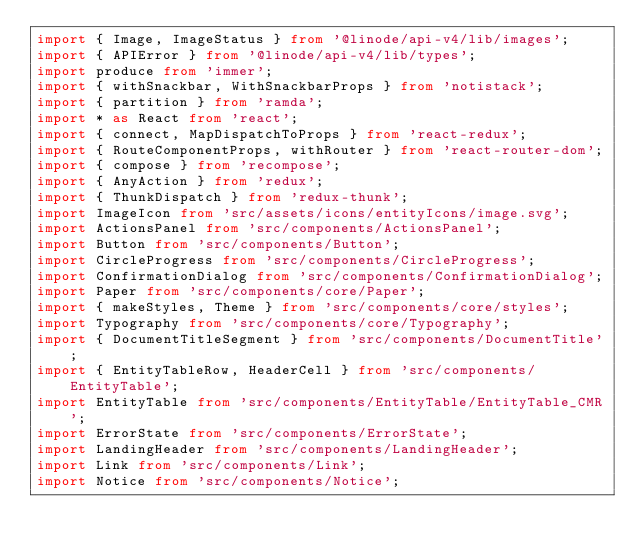Convert code to text. <code><loc_0><loc_0><loc_500><loc_500><_TypeScript_>import { Image, ImageStatus } from '@linode/api-v4/lib/images';
import { APIError } from '@linode/api-v4/lib/types';
import produce from 'immer';
import { withSnackbar, WithSnackbarProps } from 'notistack';
import { partition } from 'ramda';
import * as React from 'react';
import { connect, MapDispatchToProps } from 'react-redux';
import { RouteComponentProps, withRouter } from 'react-router-dom';
import { compose } from 'recompose';
import { AnyAction } from 'redux';
import { ThunkDispatch } from 'redux-thunk';
import ImageIcon from 'src/assets/icons/entityIcons/image.svg';
import ActionsPanel from 'src/components/ActionsPanel';
import Button from 'src/components/Button';
import CircleProgress from 'src/components/CircleProgress';
import ConfirmationDialog from 'src/components/ConfirmationDialog';
import Paper from 'src/components/core/Paper';
import { makeStyles, Theme } from 'src/components/core/styles';
import Typography from 'src/components/core/Typography';
import { DocumentTitleSegment } from 'src/components/DocumentTitle';
import { EntityTableRow, HeaderCell } from 'src/components/EntityTable';
import EntityTable from 'src/components/EntityTable/EntityTable_CMR';
import ErrorState from 'src/components/ErrorState';
import LandingHeader from 'src/components/LandingHeader';
import Link from 'src/components/Link';
import Notice from 'src/components/Notice';</code> 